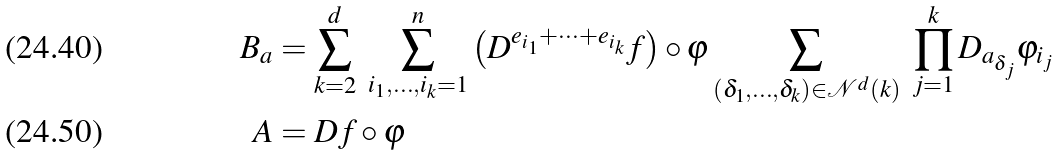Convert formula to latex. <formula><loc_0><loc_0><loc_500><loc_500>B _ { a } & = \sum _ { k = 2 } ^ { d } \ \sum _ { i _ { 1 } , \dots , i _ { k } = 1 } ^ { n } \left ( D ^ { e _ { i _ { 1 } } + \cdots + e _ { i _ { k } } } f \right ) \circ \varphi \sum _ { ( \delta _ { 1 } , \dots , \delta _ { k } ) \in \mathcal { N } ^ { d } ( k ) } \ \prod _ { j = 1 } ^ { k } D _ { a _ { \delta _ { j } } } \varphi _ { i _ { j } } \\ A & = D f \circ \varphi</formula> 